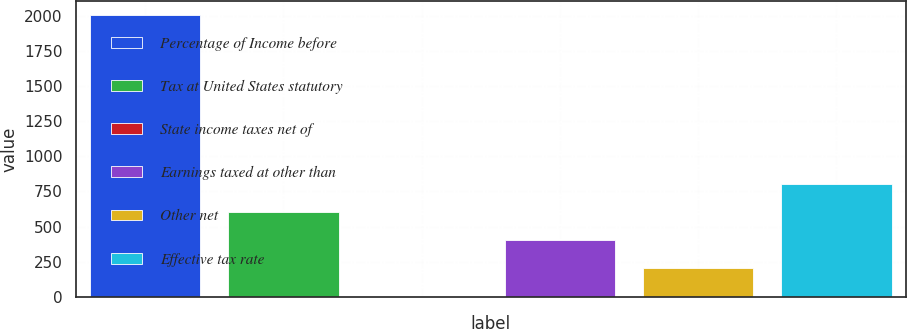<chart> <loc_0><loc_0><loc_500><loc_500><bar_chart><fcel>Percentage of Income before<fcel>Tax at United States statutory<fcel>State income taxes net of<fcel>Earnings taxed at other than<fcel>Other net<fcel>Effective tax rate<nl><fcel>2005<fcel>602.13<fcel>0.9<fcel>401.72<fcel>201.31<fcel>802.54<nl></chart> 